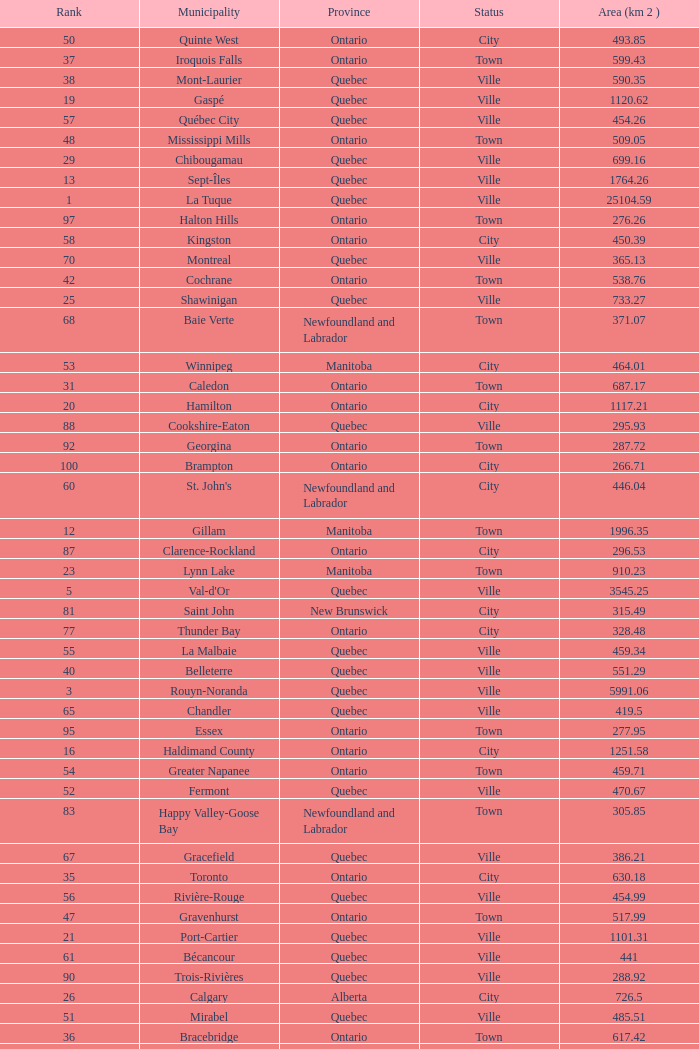What's the total of Rank that has an Area (KM 2) of 1050.14? 22.0. 